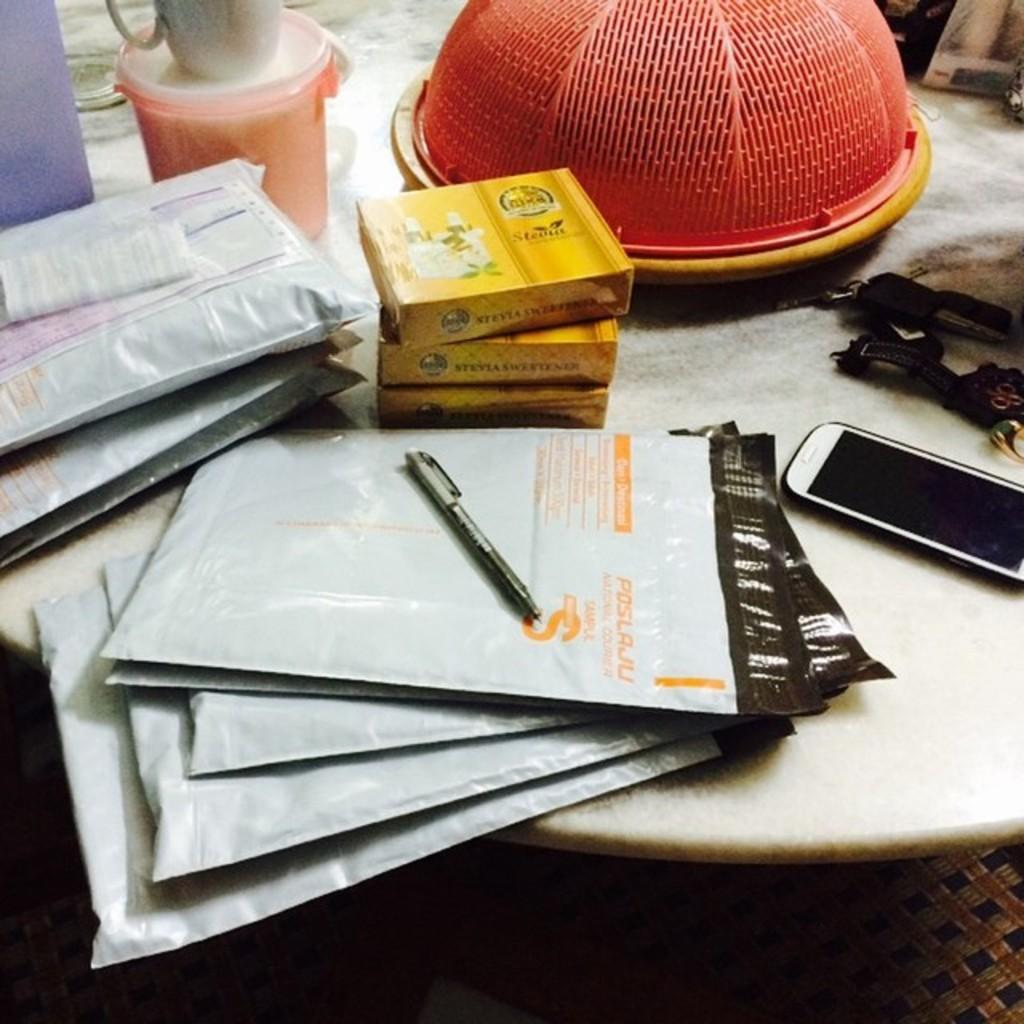What piece of furniture is present in the image? There is a table in the image. What writing instrument can be seen on the table? There is a pen on the table. What type of containers are on the table? There are boxes on the table. What beverage container is on the table? There is a cup on the table. What type of packaging is on the table? There are packets on the table. What electronic device is on the table? There is a mobile phone on the table. What time-keeping device is on the table? There is a watch on the table. What accessory is on the table? There is a key chain on the table. What other objects are on the table? There are other objects on the table. What part of the room is visible in the image? The floor is visible in the image. What type of weather can be seen in the image? The image does not depict any weather conditions; it is focused on the table and its contents. What part of a car engine is visible in the image? There is no car engine present in the image; it features a table with various objects on it. 